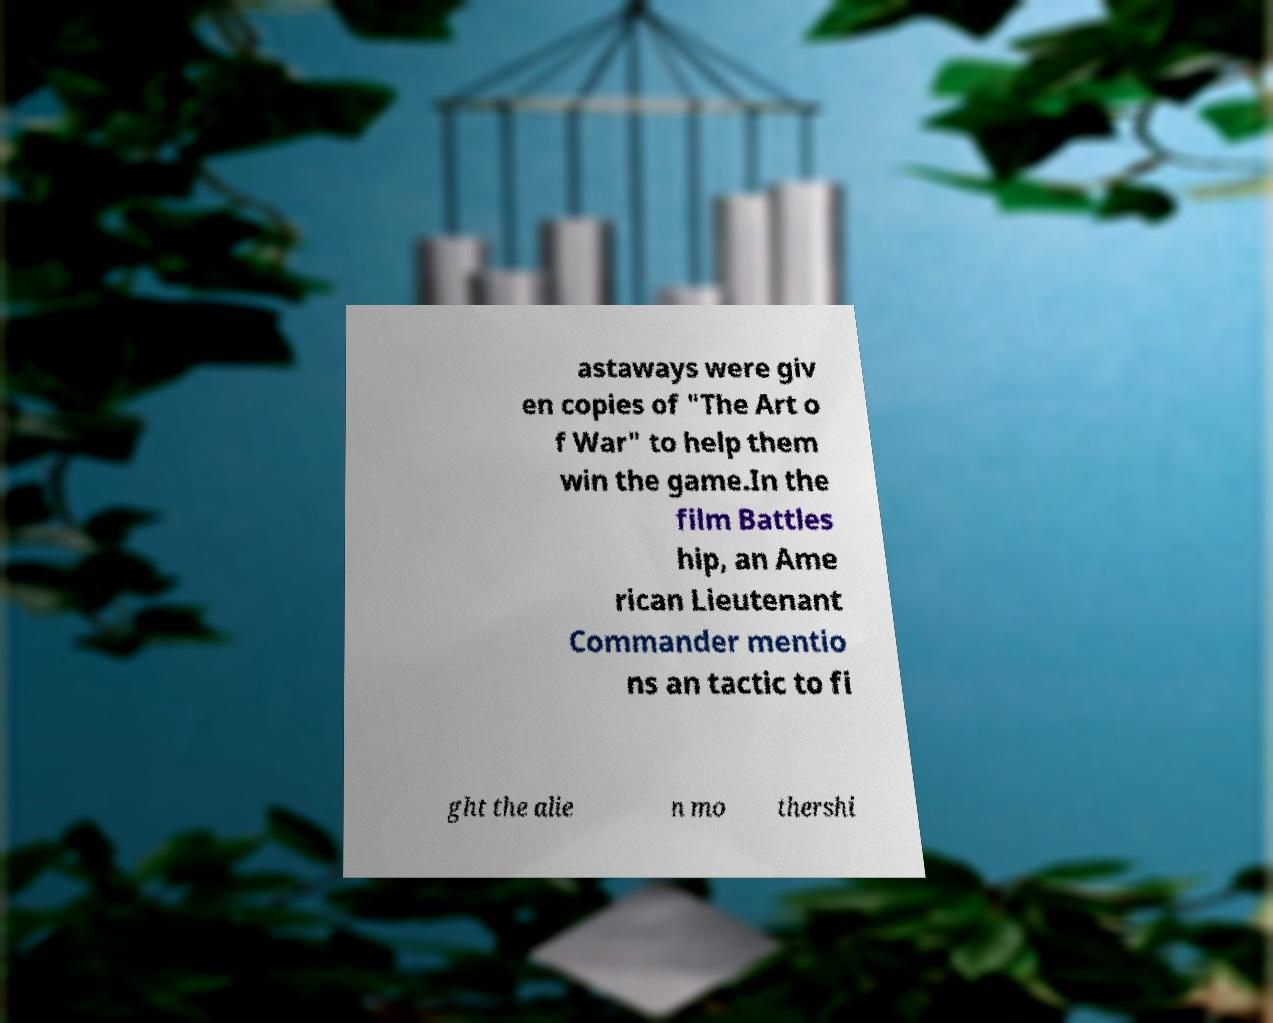Please read and relay the text visible in this image. What does it say? astaways were giv en copies of "The Art o f War" to help them win the game.In the film Battles hip, an Ame rican Lieutenant Commander mentio ns an tactic to fi ght the alie n mo thershi 